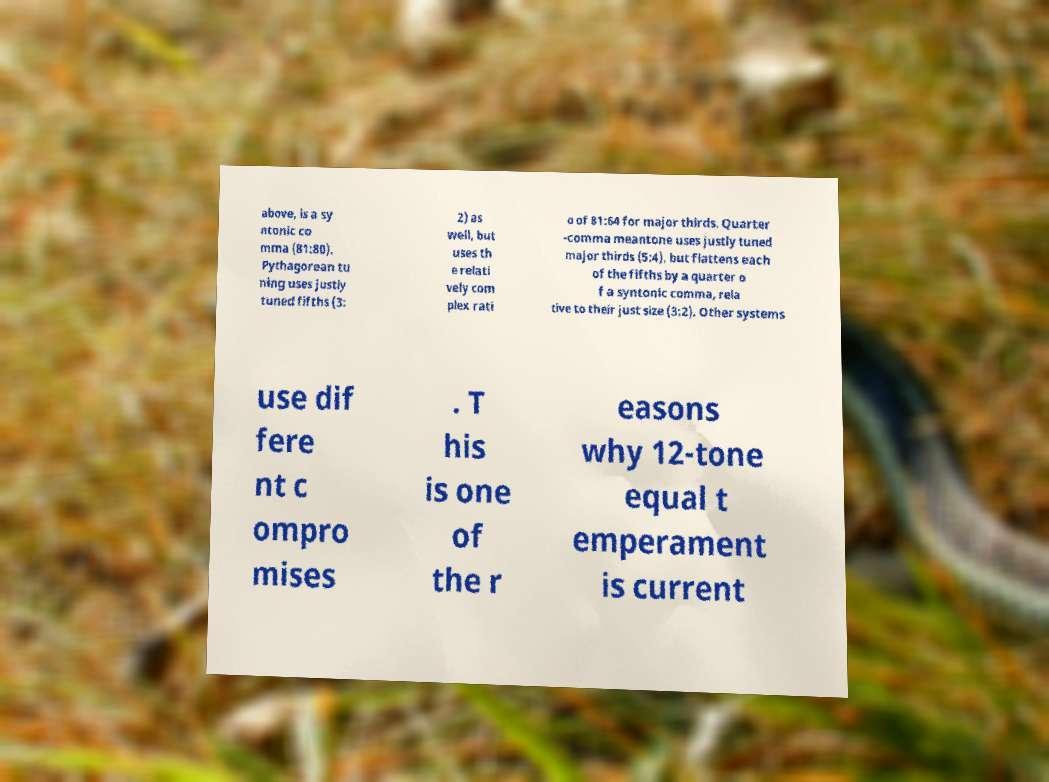Please identify and transcribe the text found in this image. above, is a sy ntonic co mma (81:80). Pythagorean tu ning uses justly tuned fifths (3: 2) as well, but uses th e relati vely com plex rati o of 81:64 for major thirds. Quarter -comma meantone uses justly tuned major thirds (5:4), but flattens each of the fifths by a quarter o f a syntonic comma, rela tive to their just size (3:2). Other systems use dif fere nt c ompro mises . T his is one of the r easons why 12-tone equal t emperament is current 